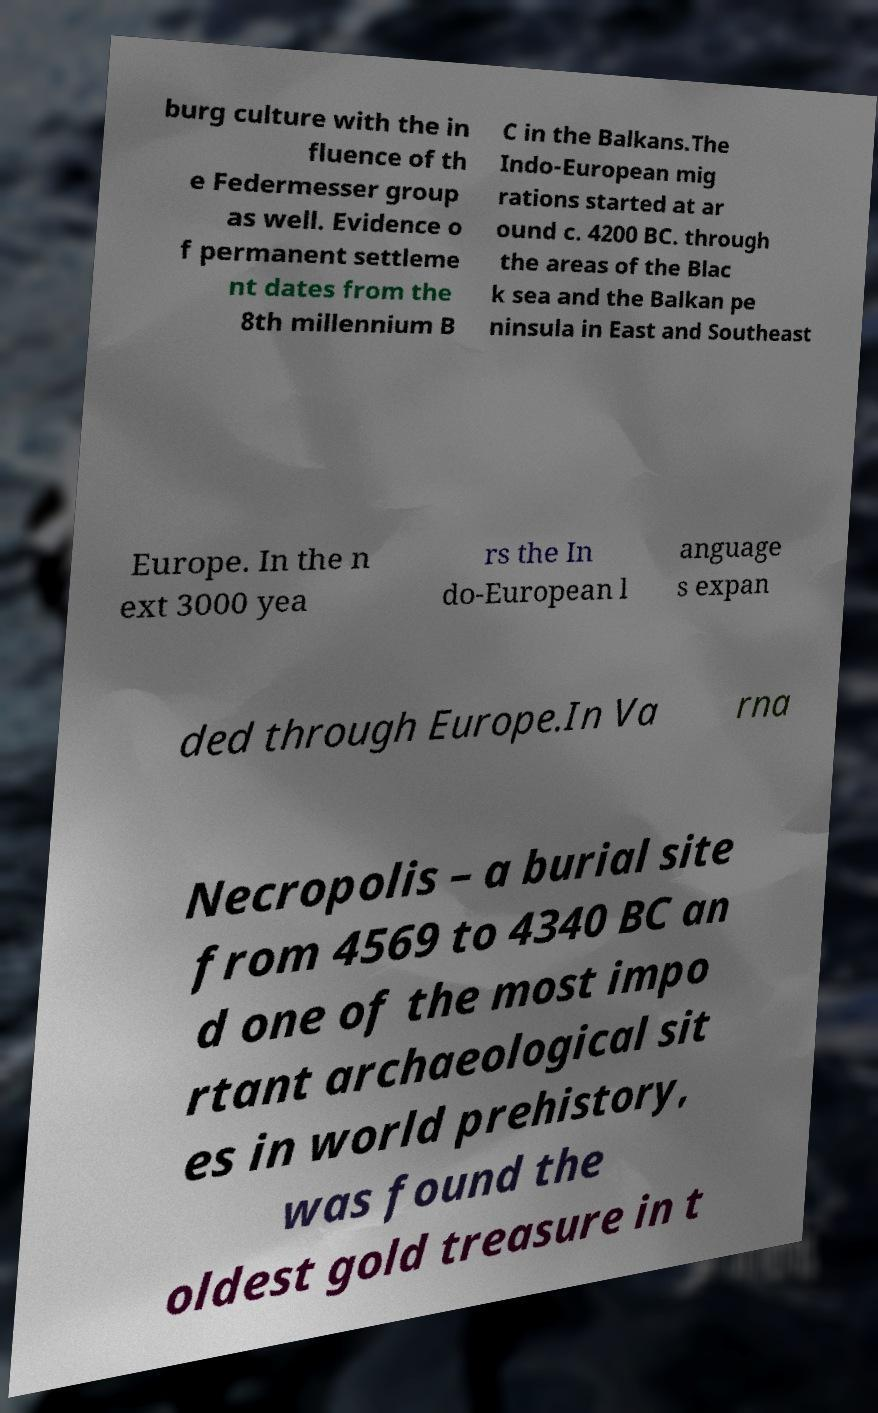For documentation purposes, I need the text within this image transcribed. Could you provide that? burg culture with the in fluence of th e Federmesser group as well. Evidence o f permanent settleme nt dates from the 8th millennium B C in the Balkans.The Indo-European mig rations started at ar ound c. 4200 BC. through the areas of the Blac k sea and the Balkan pe ninsula in East and Southeast Europe. In the n ext 3000 yea rs the In do-European l anguage s expan ded through Europe.In Va rna Necropolis – a burial site from 4569 to 4340 BC an d one of the most impo rtant archaeological sit es in world prehistory, was found the oldest gold treasure in t 